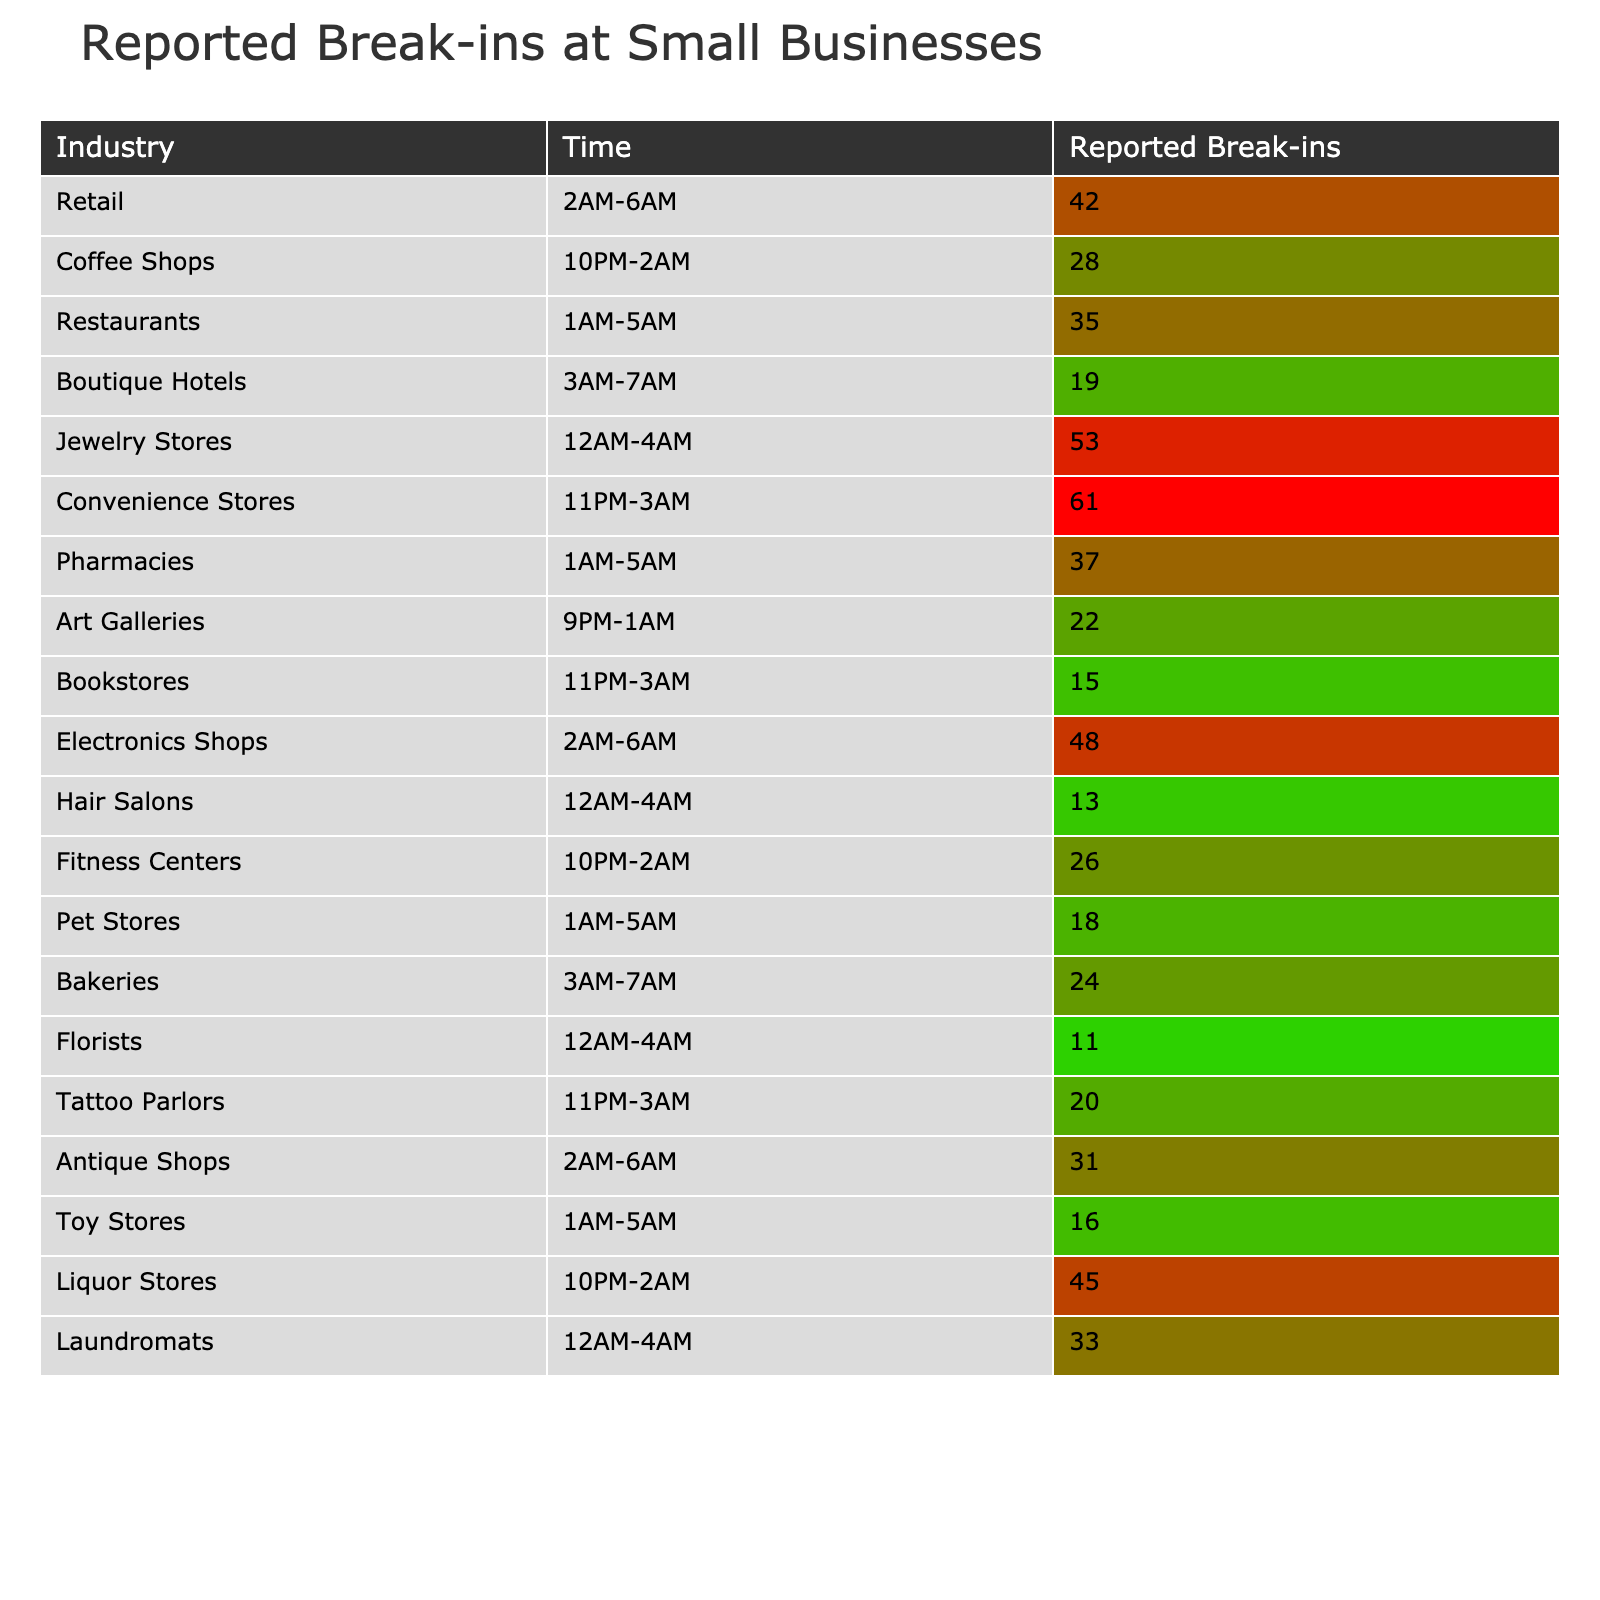What is the industry with the highest number of reported break-ins? The table shows that Jewelry Stores have the highest reported break-ins with a total of 53.
Answer: Jewelry Stores How many reported break-ins occurred in Convenience Stores? Convenience Stores are listed in the table with 61 reported break-ins.
Answer: 61 What time period has the highest number of break-ins reported for Coffee Shops? Coffee Shops show a total of 28 break-ins reported during the time period of 10 PM to 2 AM.
Answer: 10 PM to 2 AM What is the total number of reported break-ins for Restaurants and Bakeries combined? Restaurants have 35 reported break-ins and Bakeries have 24. Adding these gives 35 + 24 = 59.
Answer: 59 Which industry has the least reported break-ins, according to the table? The table displays Florists with the least reported break-ins at a total of 11.
Answer: Florists What is the average number of reported break-ins for the industries that have break-ins reported during the hours of 1 AM to 5 AM? The industries with reported break-ins in that timeframe are Restaurants (35), Pharmacies (37), Pet Stores (18), and Toy Stores (16). The sum is 35 + 37 + 18 + 16 = 106. With 4 industries to average, 106 / 4 = 26.5.
Answer: 26.5 Is there any industry listed with reported break-ins only during the day? No, all reported break-ins in the table occur during nighttime hours, thus the answer is no.
Answer: No What is the difference in reported break-ins between Liquor Stores and Convenience Stores? Liquor Stores report 45 break-ins while Convenience Stores report 61. The difference is 61 - 45 = 16.
Answer: 16 How many total reported break-ins are there for all the industries combined? To find the total, sum the reported break-ins: 42 + 28 + 35 + 19 + 53 + 61 + 37 + 22 + 15 + 48 + 13 + 26 + 18 + 24 + 11 + 20 + 31 + 16 + 45 + 33 =  466.
Answer: 466 Which time period has the least reported break-ins from the data provided? After reviewing the table, Hair Salons during the time of 12 AM to 4 AM have the least reported break-ins with only 13 incidences.
Answer: Hair Salons (12 AM to 4 AM) 